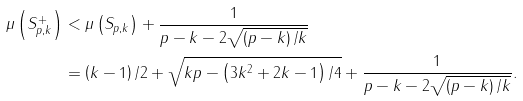Convert formula to latex. <formula><loc_0><loc_0><loc_500><loc_500>\mu \left ( S _ { p , k } ^ { + } \right ) & < \mu \left ( S _ { p , k } \right ) + \frac { 1 } { p - k - 2 \sqrt { \left ( p - k \right ) / k } } \\ & = \left ( k - 1 \right ) / 2 + \sqrt { k p - \left ( 3 k ^ { 2 } + 2 k - 1 \right ) / 4 } + \frac { 1 } { p - k - 2 \sqrt { \left ( p - k \right ) / k } } .</formula> 